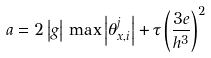Convert formula to latex. <formula><loc_0><loc_0><loc_500><loc_500>a = 2 \left | g \right | \, \max \left | \theta _ { x , i } ^ { j } \right | + \tau \left ( \frac { 3 e } { h ^ { 3 } } \right ) ^ { 2 }</formula> 